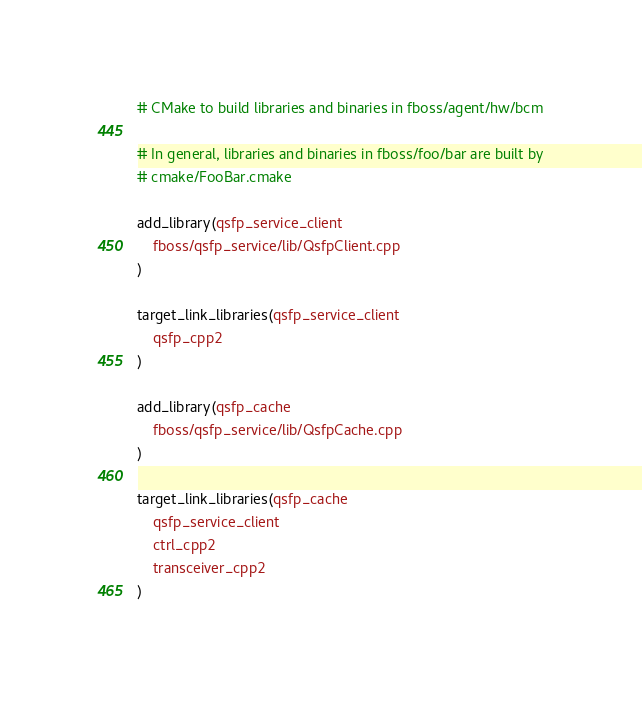<code> <loc_0><loc_0><loc_500><loc_500><_CMake_># CMake to build libraries and binaries in fboss/agent/hw/bcm

# In general, libraries and binaries in fboss/foo/bar are built by
# cmake/FooBar.cmake

add_library(qsfp_service_client
    fboss/qsfp_service/lib/QsfpClient.cpp
)

target_link_libraries(qsfp_service_client
    qsfp_cpp2
)

add_library(qsfp_cache
    fboss/qsfp_service/lib/QsfpCache.cpp
)

target_link_libraries(qsfp_cache
    qsfp_service_client
    ctrl_cpp2
    transceiver_cpp2
)
</code> 